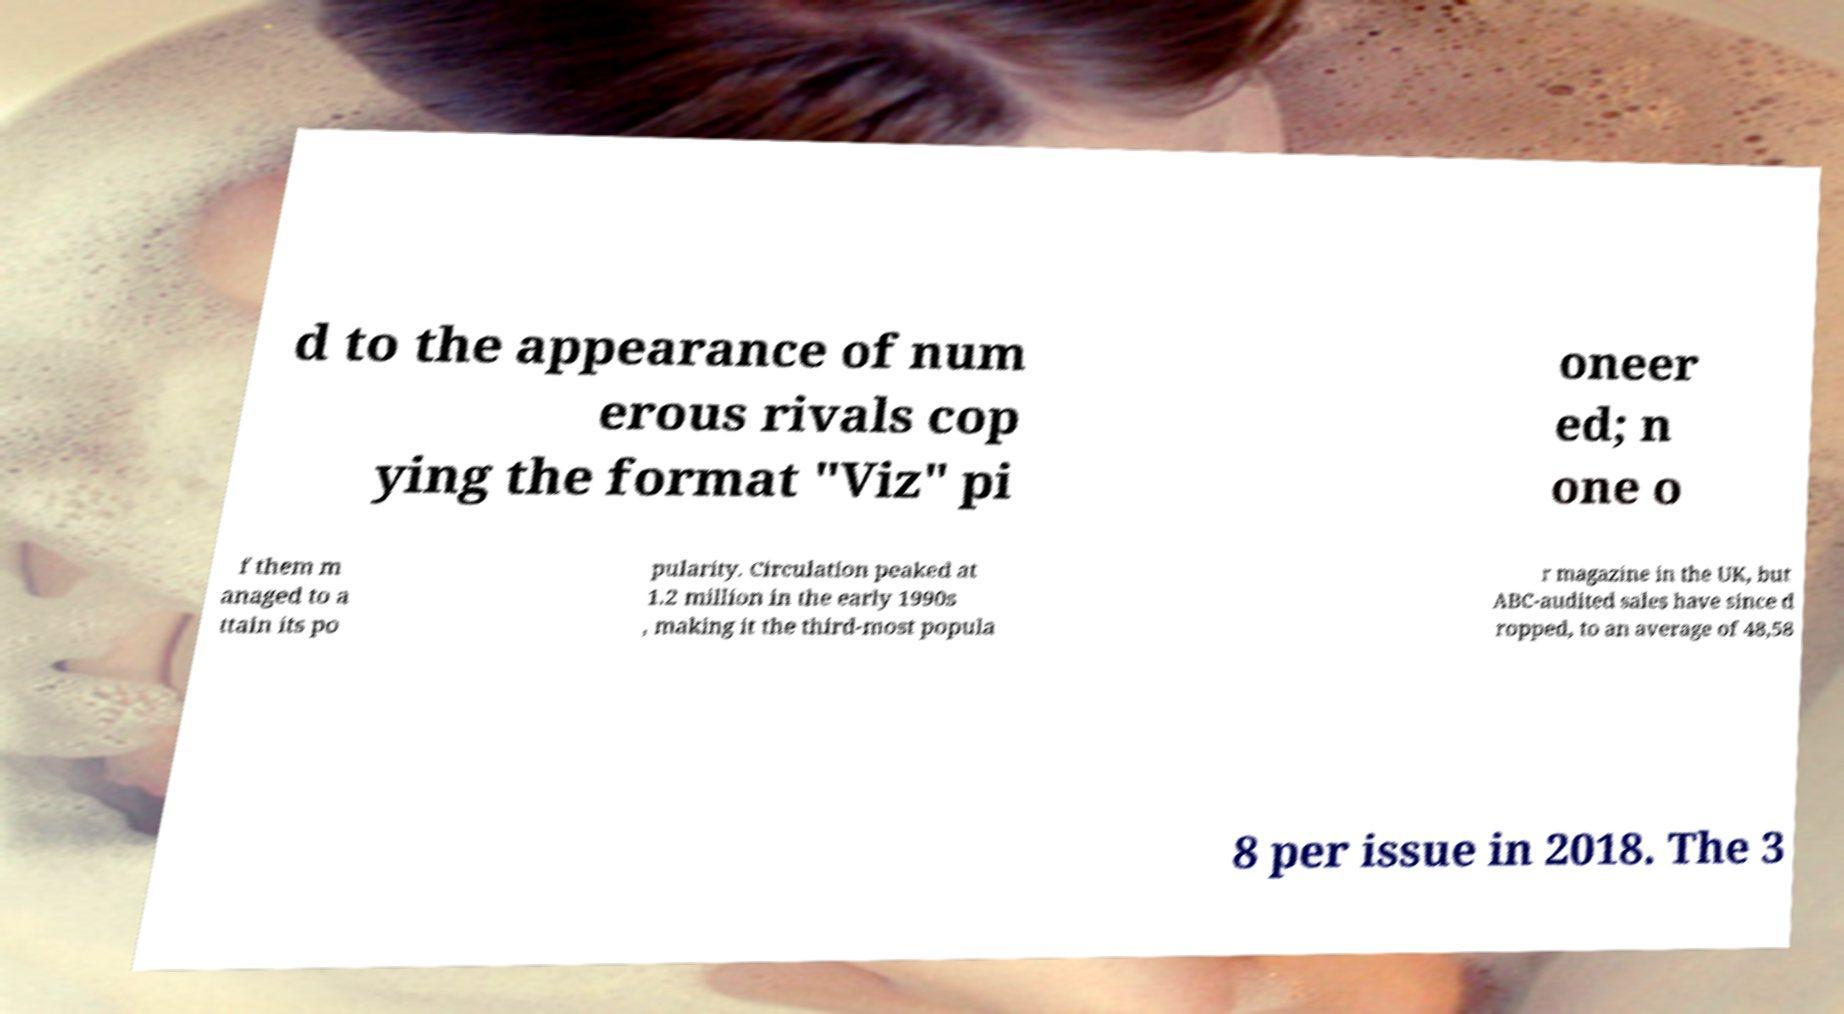Please read and relay the text visible in this image. What does it say? d to the appearance of num erous rivals cop ying the format "Viz" pi oneer ed; n one o f them m anaged to a ttain its po pularity. Circulation peaked at 1.2 million in the early 1990s , making it the third-most popula r magazine in the UK, but ABC-audited sales have since d ropped, to an average of 48,58 8 per issue in 2018. The 3 